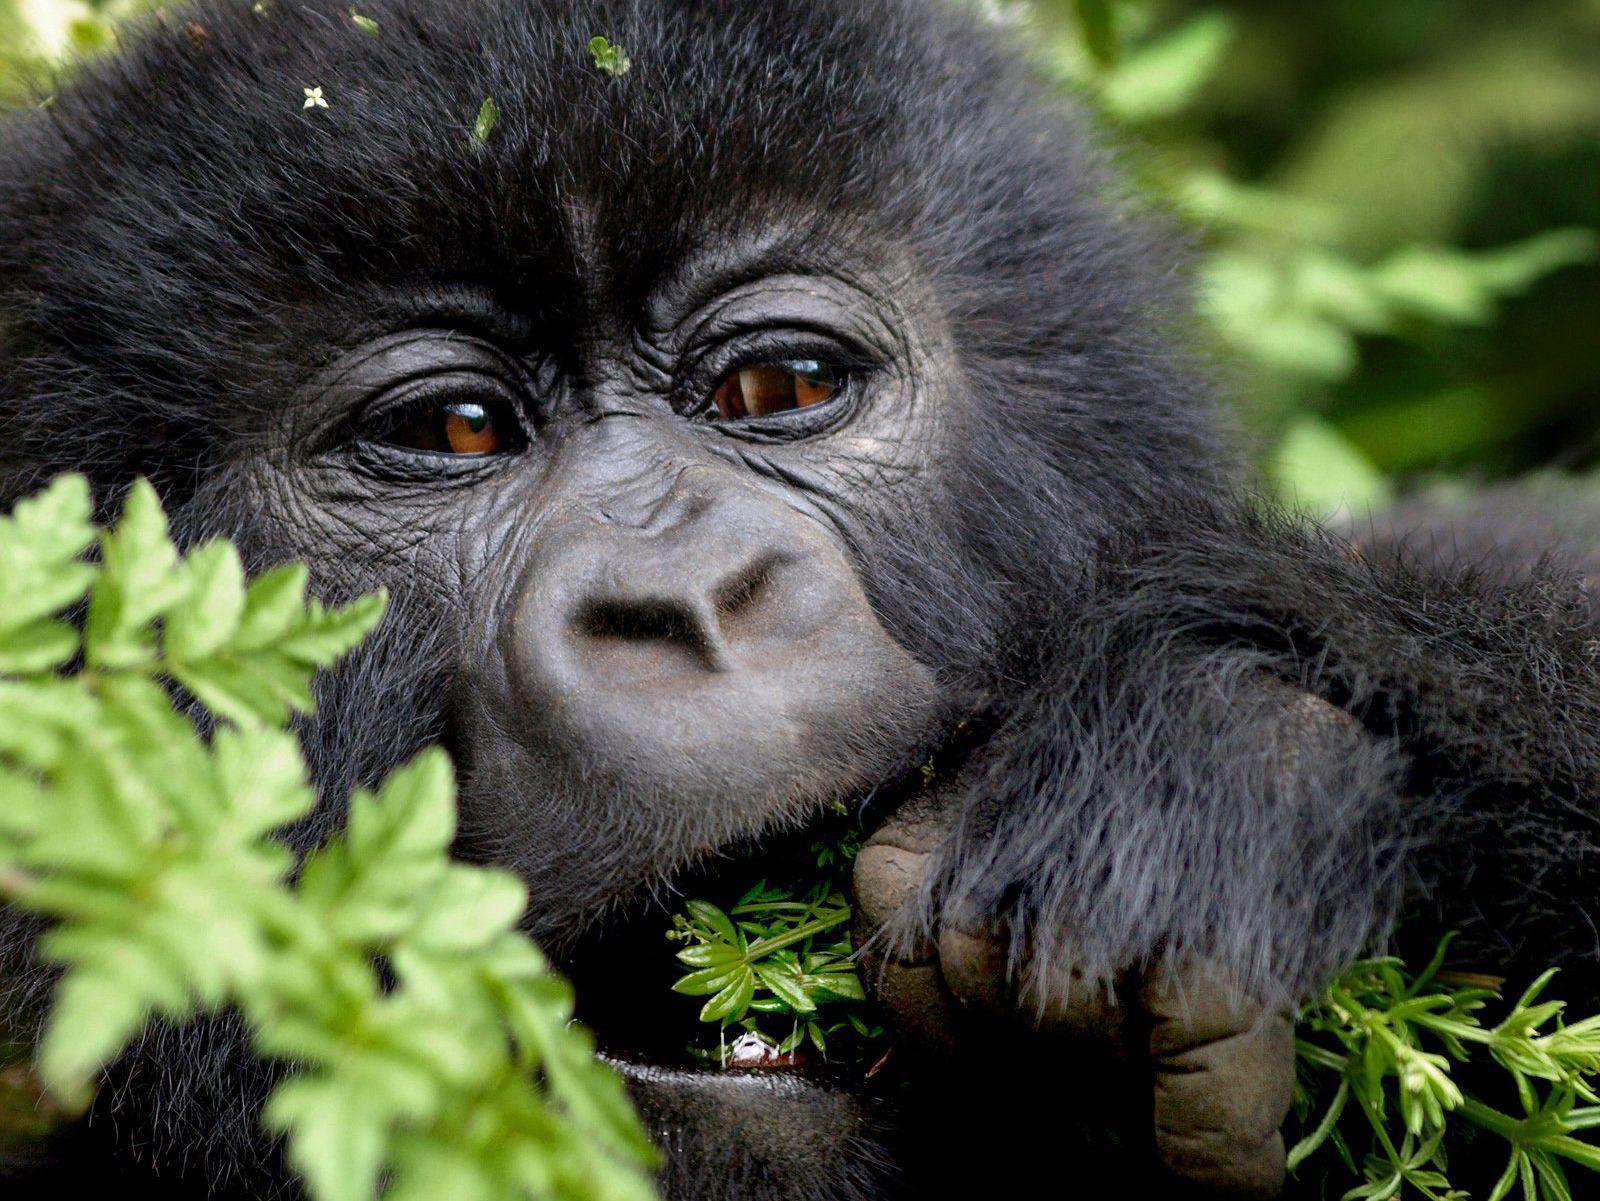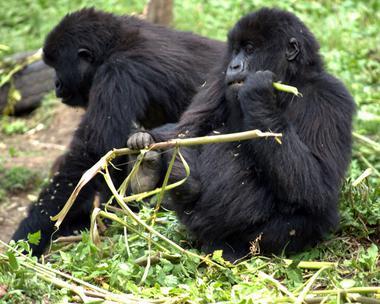The first image is the image on the left, the second image is the image on the right. For the images shown, is this caption "The left image shows one gorilla holding a leafless stalk to its mouth, and the right image includes a fuzzy-haired young gorilla looking over its shoulder toward the camera." true? Answer yes or no. No. The first image is the image on the left, the second image is the image on the right. Analyze the images presented: Is the assertion "One of the images in the pair includes a baby gorilla." valid? Answer yes or no. No. 